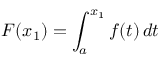<formula> <loc_0><loc_0><loc_500><loc_500>F ( x _ { 1 } ) = \int _ { a } ^ { x _ { 1 } } f ( t ) \, d t</formula> 